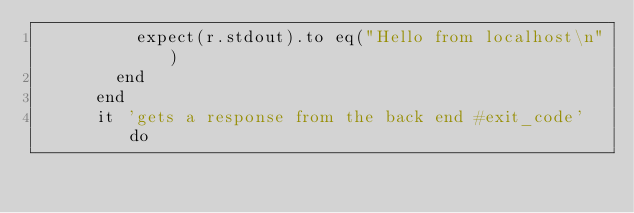Convert code to text. <code><loc_0><loc_0><loc_500><loc_500><_Ruby_>          expect(r.stdout).to eq("Hello from localhost\n")
        end
      end
      it 'gets a response from the back end #exit_code' do</code> 